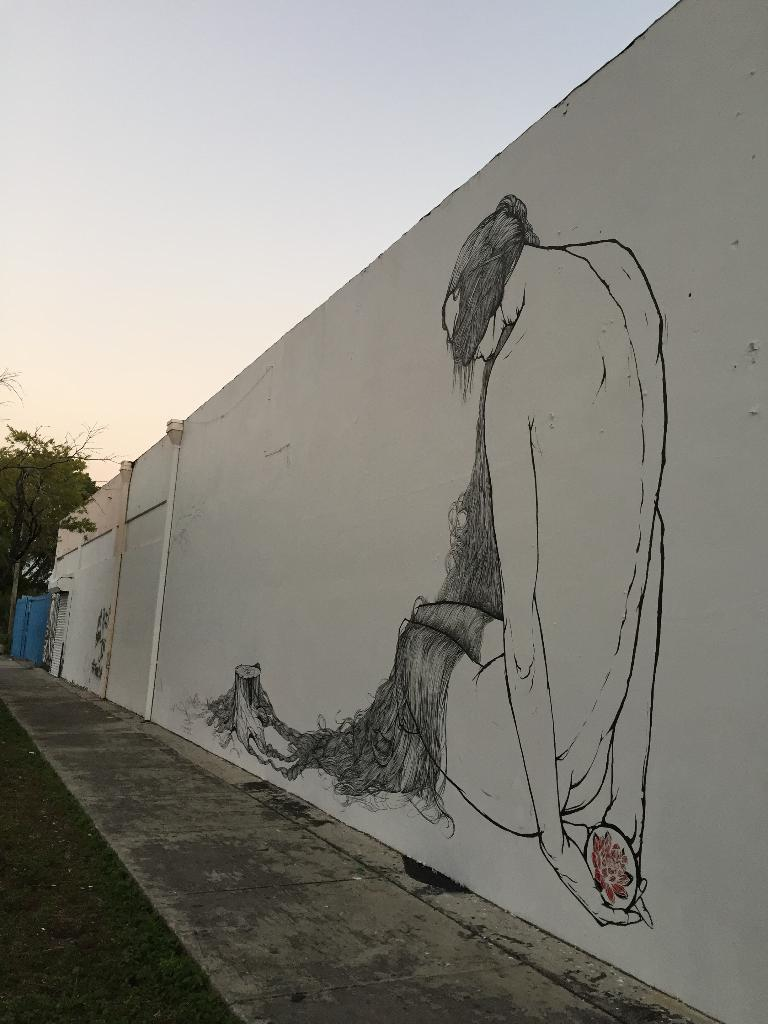What is depicted on the wall in the foreground of the image? There is a painting on the wall in the foreground of the image. What can be seen at the bottom of the image? There is a road at the bottom of the image. What type of natural element is visible in the background of the image? There is a tree in the background of the image. How many blue objects can be seen in the background of the image? There are two blue objects in the background of the image. What is visible in the sky in the background of the image? The sky is visible in the background of the image. Can you tell me how many knees are visible in the image? There are no knees visible in the image. What type of stream is present in the image? There is no stream present in the image. 